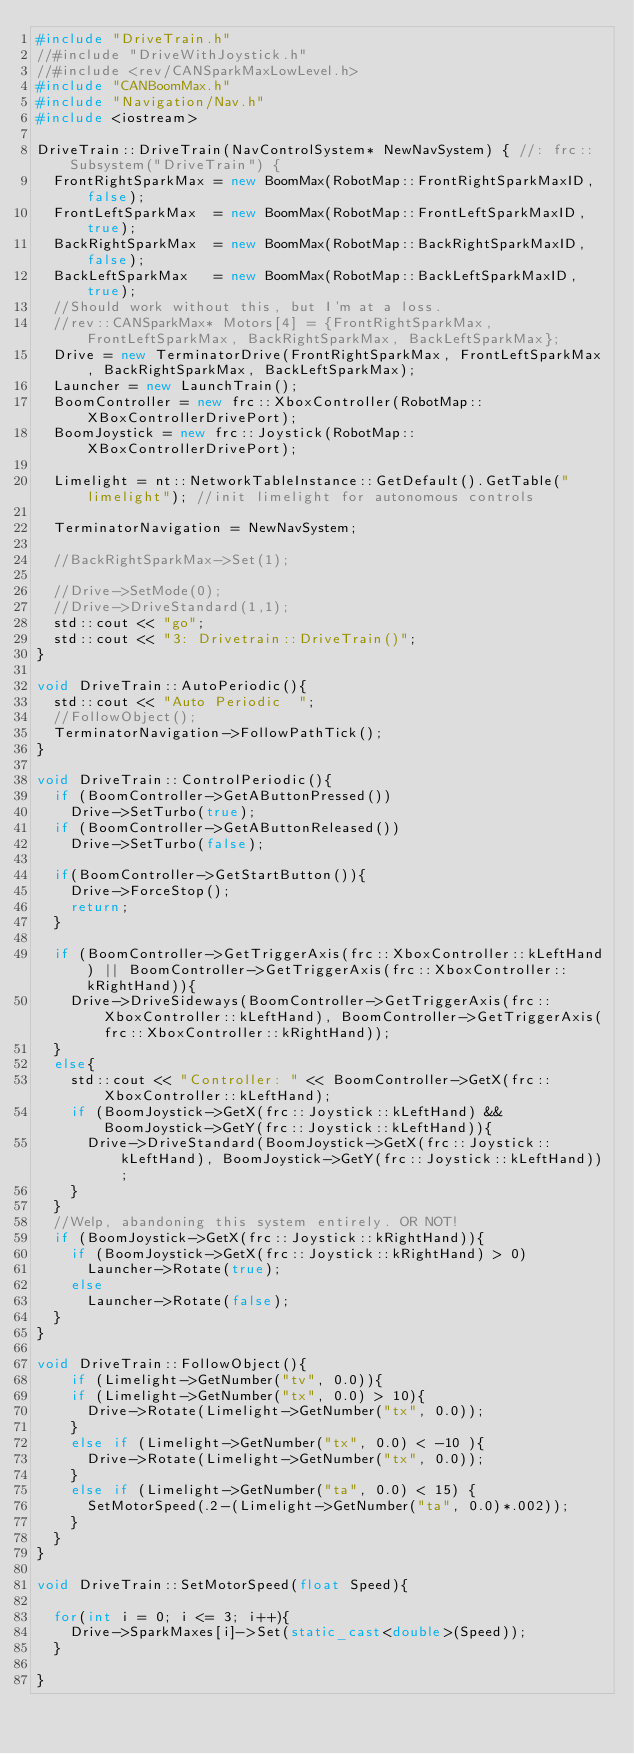<code> <loc_0><loc_0><loc_500><loc_500><_C++_>#include "DriveTrain.h"
//#include "DriveWithJoystick.h"
//#include <rev/CANSparkMaxLowLevel.h>
#include "CANBoomMax.h"
#include "Navigation/Nav.h"
#include <iostream>

DriveTrain::DriveTrain(NavControlSystem* NewNavSystem) { //: frc::Subsystem("DriveTrain") {
	FrontRightSparkMax = new BoomMax(RobotMap::FrontRightSparkMaxID, false);
	FrontLeftSparkMax  = new BoomMax(RobotMap::FrontLeftSparkMaxID, true);
	BackRightSparkMax  = new BoomMax(RobotMap::BackRightSparkMaxID, false);
	BackLeftSparkMax   = new BoomMax(RobotMap::BackLeftSparkMaxID, true);
	//Should work without this, but I'm at a loss.
	//rev::CANSparkMax* Motors[4] = {FrontRightSparkMax, FrontLeftSparkMax, BackRightSparkMax, BackLeftSparkMax};
	Drive = new TerminatorDrive(FrontRightSparkMax, FrontLeftSparkMax, BackRightSparkMax, BackLeftSparkMax);
	Launcher = new LaunchTrain();
	BoomController = new frc::XboxController(RobotMap::XBoxControllerDrivePort);
	BoomJoystick = new frc::Joystick(RobotMap::XBoxControllerDrivePort);

	Limelight = nt::NetworkTableInstance::GetDefault().GetTable("limelight"); //init limelight for autonomous controls

	TerminatorNavigation = NewNavSystem;

	//BackRightSparkMax->Set(1);

	//Drive->SetMode(0);
	//Drive->DriveStandard(1,1);
	std::cout << "go";
	std::cout << "3: Drivetrain::DriveTrain()";
}

void DriveTrain::AutoPeriodic(){
	std::cout << "Auto Periodic  ";
	//FollowObject();
	TerminatorNavigation->FollowPathTick();
}

void DriveTrain::ControlPeriodic(){
	if (BoomController->GetAButtonPressed())
		Drive->SetTurbo(true);
	if (BoomController->GetAButtonReleased())
		Drive->SetTurbo(false);

	if(BoomController->GetStartButton()){
		Drive->ForceStop();
		return;
	}

	if (BoomController->GetTriggerAxis(frc::XboxController::kLeftHand) || BoomController->GetTriggerAxis(frc::XboxController::kRightHand)){
		Drive->DriveSideways(BoomController->GetTriggerAxis(frc::XboxController::kLeftHand), BoomController->GetTriggerAxis(frc::XboxController::kRightHand));
	}
	else{
		std::cout << "Controller: " << BoomController->GetX(frc::XboxController::kLeftHand);
		if (BoomJoystick->GetX(frc::Joystick::kLeftHand) && BoomJoystick->GetY(frc::Joystick::kLeftHand)){
			Drive->DriveStandard(BoomJoystick->GetX(frc::Joystick::kLeftHand), BoomJoystick->GetY(frc::Joystick::kLeftHand));
		}		
	}
	//Welp, abandoning this system entirely. OR NOT!
	if (BoomJoystick->GetX(frc::Joystick::kRightHand)){
		if (BoomJoystick->GetX(frc::Joystick::kRightHand) > 0)
			Launcher->Rotate(true);
		else
			Launcher->Rotate(false);
	}
}

void DriveTrain::FollowObject(){
		if (Limelight->GetNumber("tv", 0.0)){
		if (Limelight->GetNumber("tx", 0.0) > 10){
			Drive->Rotate(Limelight->GetNumber("tx", 0.0));
		}
		else if (Limelight->GetNumber("tx", 0.0) < -10 ){
			Drive->Rotate(Limelight->GetNumber("tx", 0.0));
		}
		else if (Limelight->GetNumber("ta", 0.0) < 15) {
			SetMotorSpeed(.2-(Limelight->GetNumber("ta", 0.0)*.002));
		}
	}
}

void DriveTrain::SetMotorSpeed(float Speed){

	for(int i = 0; i <= 3; i++){
		Drive->SparkMaxes[i]->Set(static_cast<double>(Speed));
	}

}</code> 